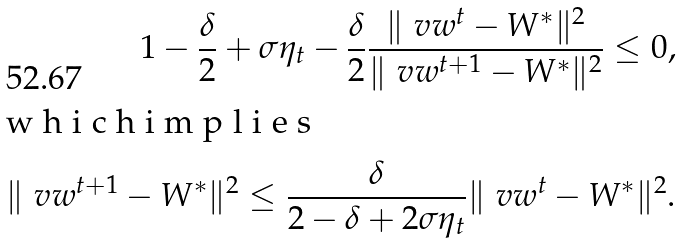<formula> <loc_0><loc_0><loc_500><loc_500>1 - \frac { \delta } { 2 } + \sigma \eta _ { t } - \frac { \delta } { 2 } \frac { \| \ v w ^ { t } - W ^ { \ast } \| ^ { 2 } } { \| \ v w ^ { t + 1 } - W ^ { \ast } \| ^ { 2 } } \leq 0 , \intertext { w h i c h i m p l i e s } \| \ v w ^ { t + 1 } - W ^ { \ast } \| ^ { 2 } \leq \frac { \delta } { 2 - \delta + 2 \sigma \eta _ { t } } \| \ v w ^ { t } - W ^ { \ast } \| ^ { 2 } .</formula> 